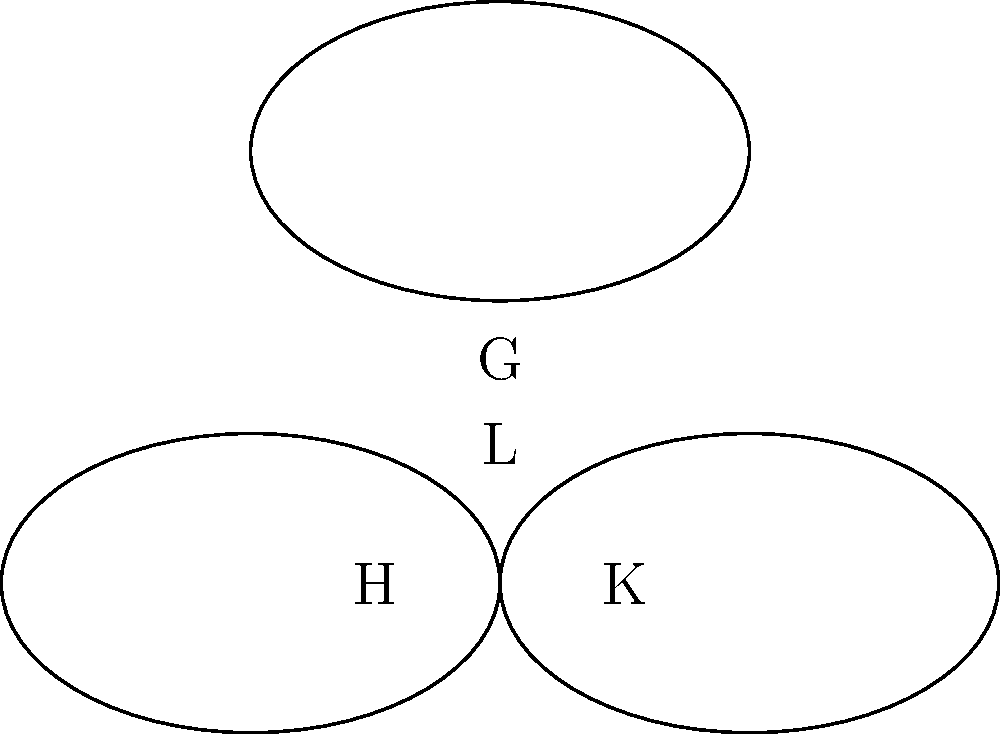In a cloud migration project, you're visualizing team structures using nested Venn diagrams. The largest group G represents all team members, while subgroups H, K, and L represent specialized teams. If the intersection of all three subgroups (H ∩ K ∩ L) contains 5 members, and each subgroup has 20 members, what is the minimum possible size of group G? To solve this problem, we'll use the principle of inclusion-exclusion and the given information about the subgroups. Let's break it down step-by-step:

1. Given:
   - Each subgroup (H, K, L) has 20 members
   - The intersection of all three subgroups (H ∩ K ∩ L) contains 5 members

2. Let's denote:
   - |H ∩ K| = |K ∩ L| = |H ∩ L| = x (assuming they're equal for the minimum case)

3. Using the inclusion-exclusion principle:
   |H ∪ K ∪ L| = |H| + |K| + |L| - |H ∩ K| - |K ∩ L| - |H ∩ L| + |H ∩ K ∩ L|
   
4. Substituting the known values:
   |G| = 20 + 20 + 20 - x - x - x + 5
   
5. Simplify:
   |G| = 60 - 3x + 5 = 65 - 3x

6. To find the minimum size of G, we need to maximize x while ensuring it's not larger than the size of each subgroup minus the common intersection:
   x ≤ 20 - 5 = 15

7. The maximum value for x is 15, so:
   |G| = 65 - 3(15) = 65 - 45 = 20

Therefore, the minimum possible size of group G is 20 members.
Answer: 20 members 